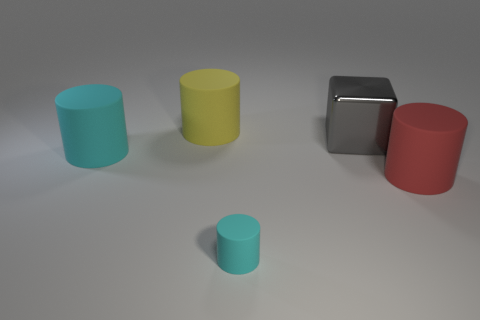Does the tiny object have the same color as the large rubber cylinder that is on the left side of the yellow matte cylinder?
Your response must be concise. Yes. There is a big yellow object; does it have the same shape as the big rubber thing that is to the right of the big shiny cube?
Your answer should be compact. Yes. What number of big objects are either red rubber cylinders or blocks?
Offer a very short reply. 2. What is the size of the matte thing that is the same color as the tiny rubber cylinder?
Your answer should be very brief. Large. What is the color of the matte cylinder that is in front of the big matte object that is to the right of the tiny object?
Provide a succinct answer. Cyan. Does the tiny cyan thing have the same material as the big gray cube that is behind the big cyan object?
Provide a succinct answer. No. What is the big cylinder that is behind the big gray object made of?
Your answer should be very brief. Rubber. Are there the same number of big cyan cylinders that are behind the metal block and red rubber things?
Your response must be concise. No. There is a large gray thing on the left side of the cylinder to the right of the big gray metal block; what is its material?
Offer a terse response. Metal. The big matte thing that is both on the left side of the gray thing and in front of the gray shiny cube has what shape?
Your answer should be very brief. Cylinder. 